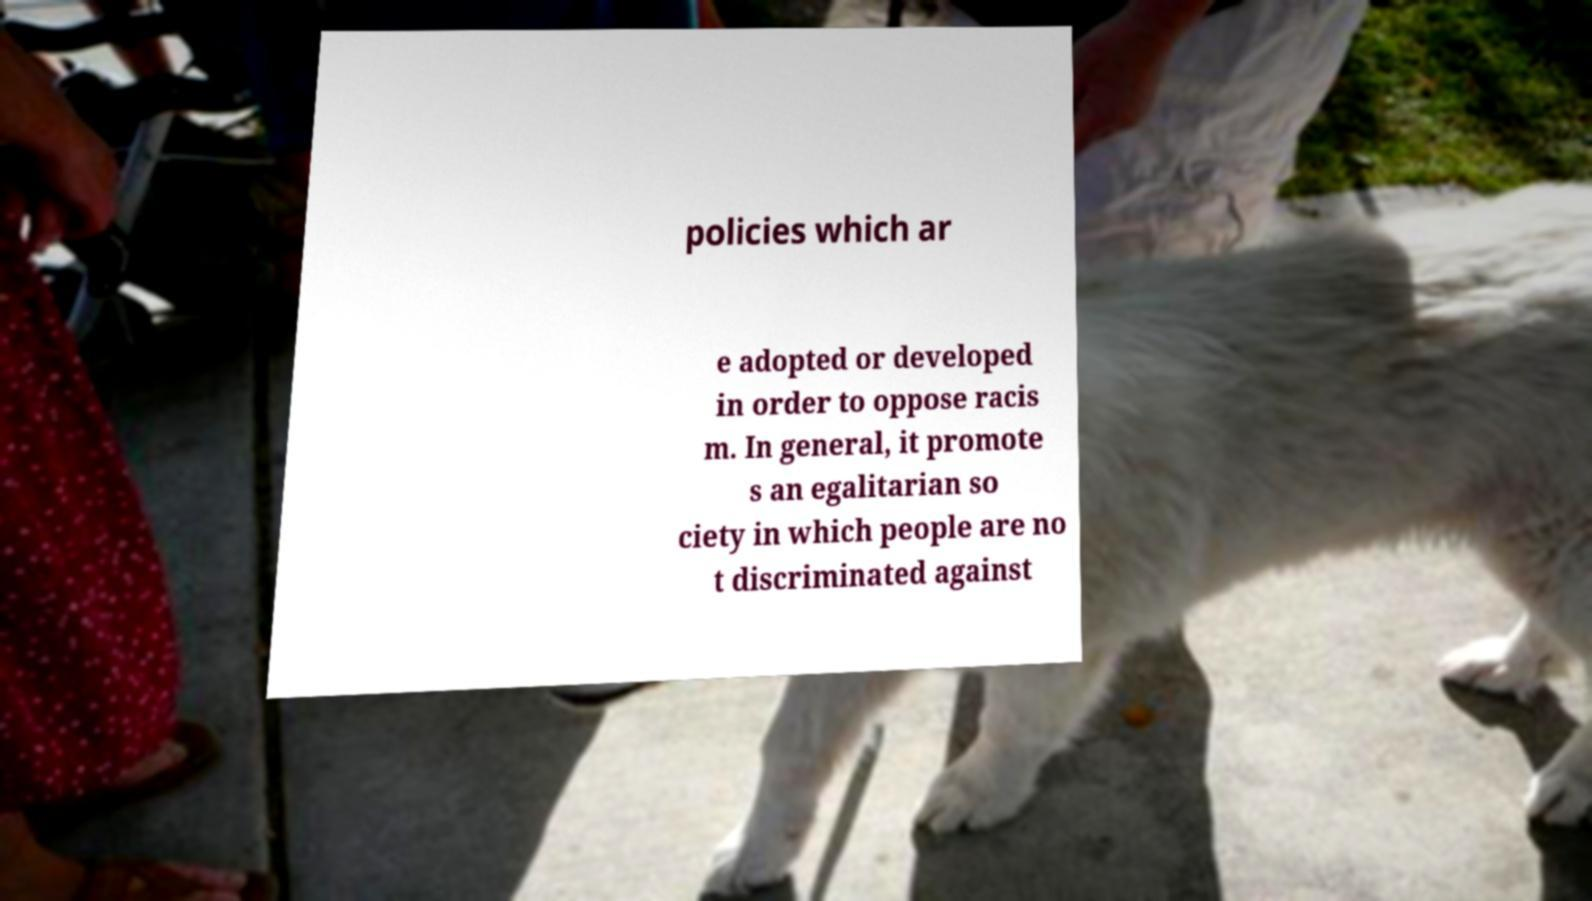There's text embedded in this image that I need extracted. Can you transcribe it verbatim? policies which ar e adopted or developed in order to oppose racis m. In general, it promote s an egalitarian so ciety in which people are no t discriminated against 